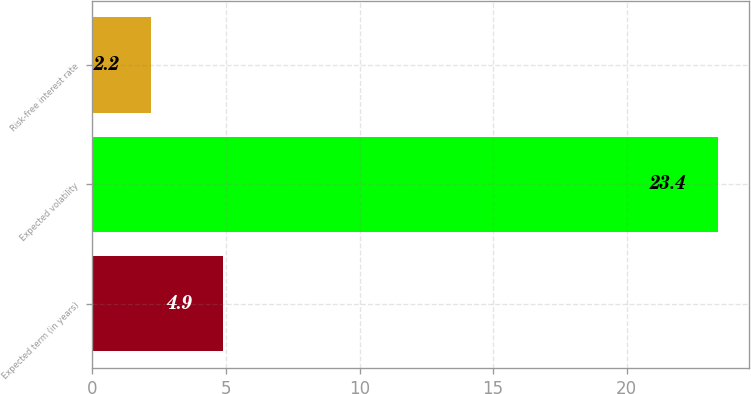Convert chart. <chart><loc_0><loc_0><loc_500><loc_500><bar_chart><fcel>Expected term (in years)<fcel>Expected volatility<fcel>Risk-free interest rate<nl><fcel>4.9<fcel>23.4<fcel>2.2<nl></chart> 